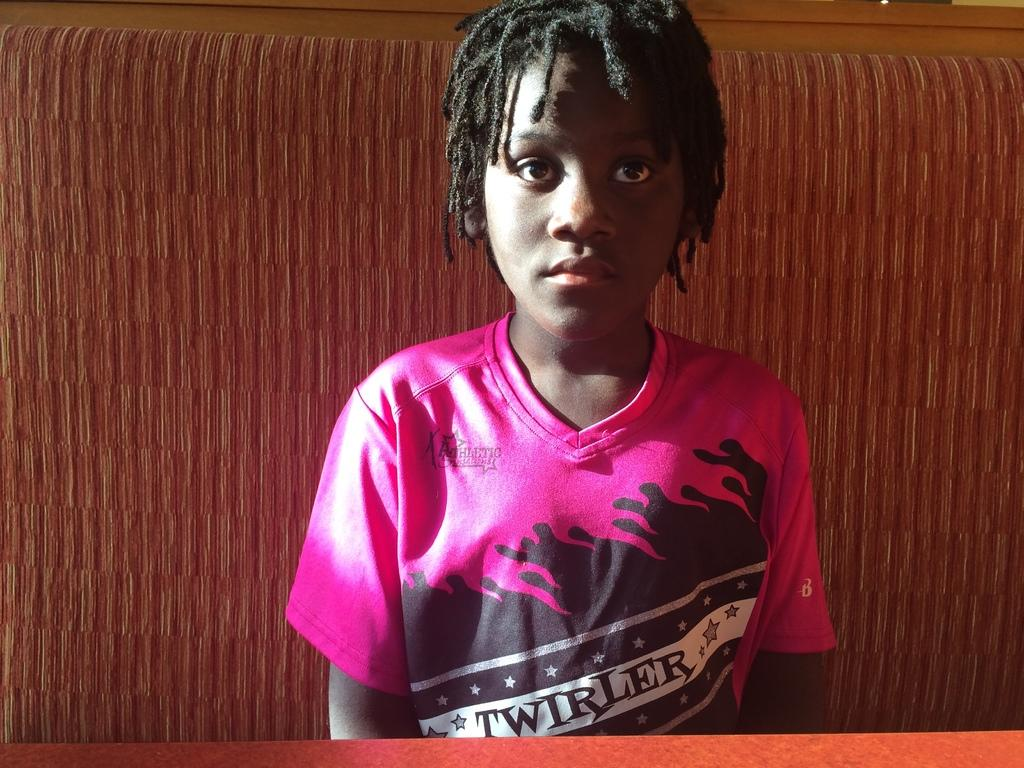What is the main subject of the picture? The main subject of the picture is a kid. What is the kid wearing in the picture? The kid is wearing a pink t-shirt. What type of lettuce is the kid holding in the picture? There is no lettuce present in the picture; the kid is wearing a pink t-shirt. 